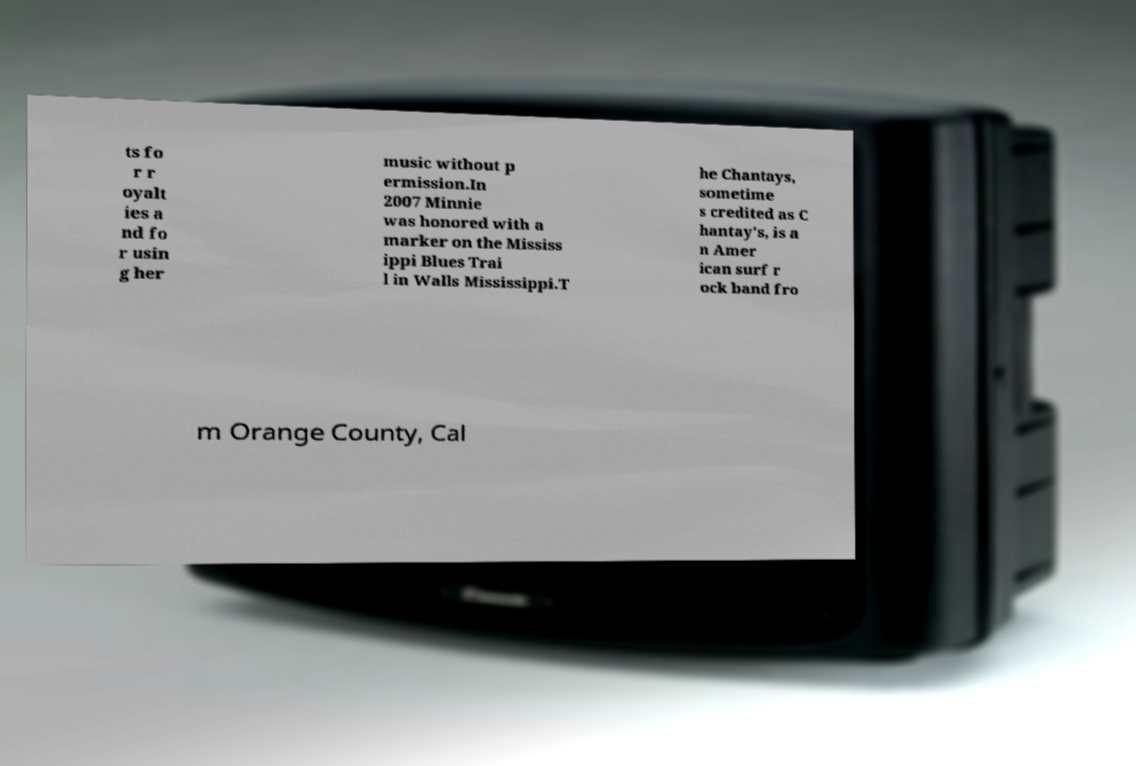Can you accurately transcribe the text from the provided image for me? ts fo r r oyalt ies a nd fo r usin g her music without p ermission.In 2007 Minnie was honored with a marker on the Mississ ippi Blues Trai l in Walls Mississippi.T he Chantays, sometime s credited as C hantay's, is a n Amer ican surf r ock band fro m Orange County, Cal 